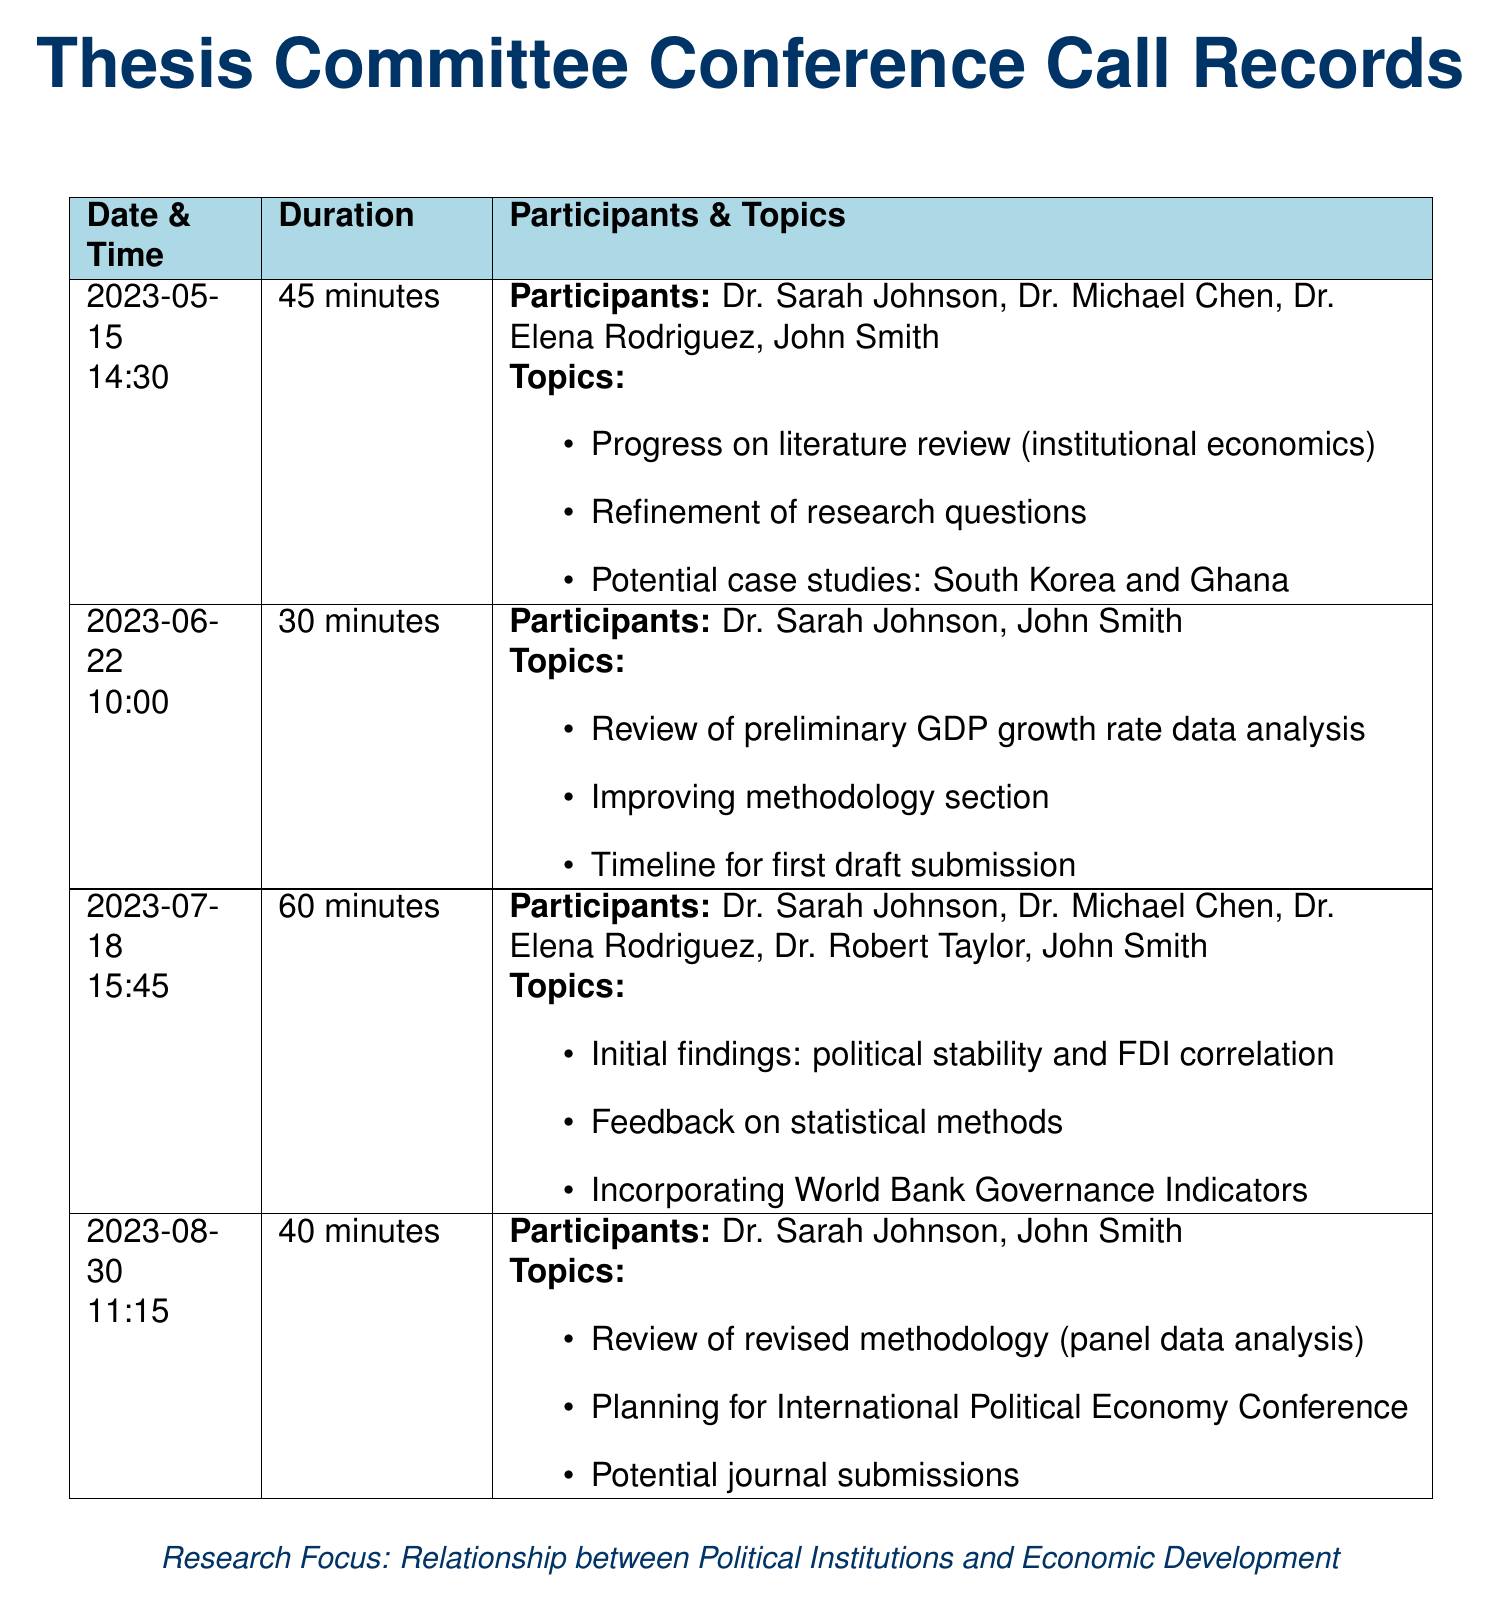What is the duration of the call on May 15, 2023? The duration is specified next to the date for each conference call, which is 45 minutes on May 15, 2023.
Answer: 45 minutes Who participated in the conference call on June 22, 2023? The participants for that call are listed under the date, which includes Dr. Sarah Johnson and John Smith.
Answer: Dr. Sarah Johnson, John Smith What methodology was reviewed on August 30, 2023? The document states that the revised methodology discussed in the call was panel data analysis.
Answer: panel data analysis How many participants were involved in the call on July 18, 2023? The number of participants can be counted from the list provided for that date, which includes five individuals.
Answer: 5 What topic was discussed regarding case studies in the call on May 15, 2023? The topic concerning potential case studies is noted in the list, which mentions South Korea and Ghana.
Answer: South Korea and Ghana What was the focus of the research as mentioned in the document? The focus of the research can be found at the bottom, summarized as the relationship between political institutions and economic development.
Answer: Relationship between Political Institutions and Economic Development What feedback was sought in the July 18, 2023 call? The feedback topic is explicitly stated in the list of topics for that date as feedback on statistical methods.
Answer: Feedback on statistical methods What conference was planned during the call on August 30, 2023? The document specifies planning for the International Political Economy Conference in that call.
Answer: International Political Economy Conference 